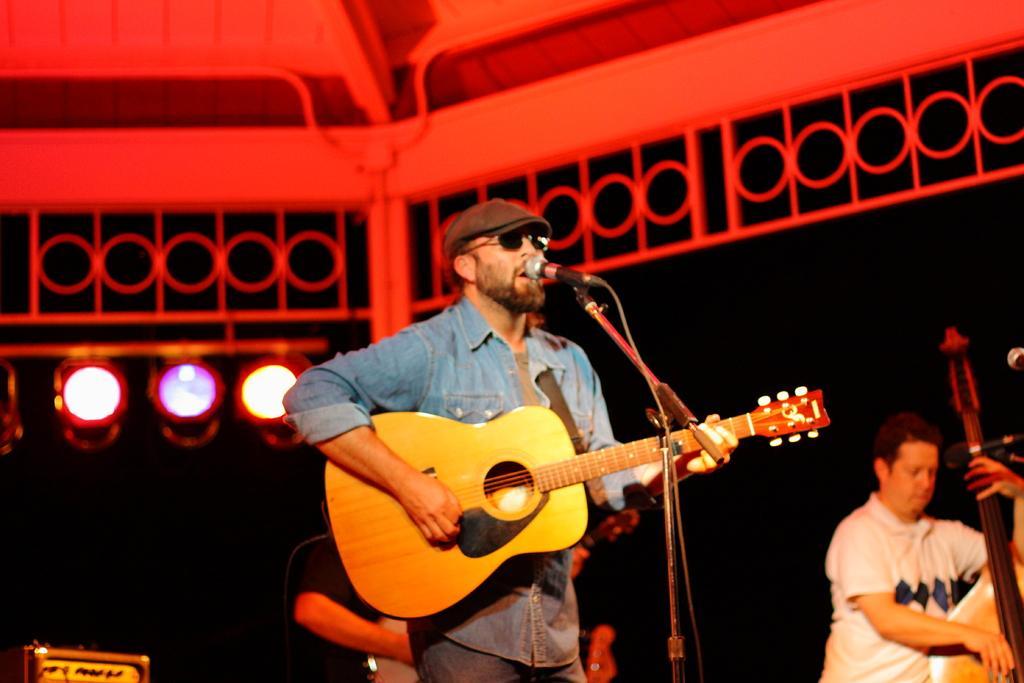In one or two sentences, can you explain what this image depicts? This person standing and holding guitar and singing and wear cap. This person holding musical instrument. On the background we can see focusing lights. There microphone with stand. 